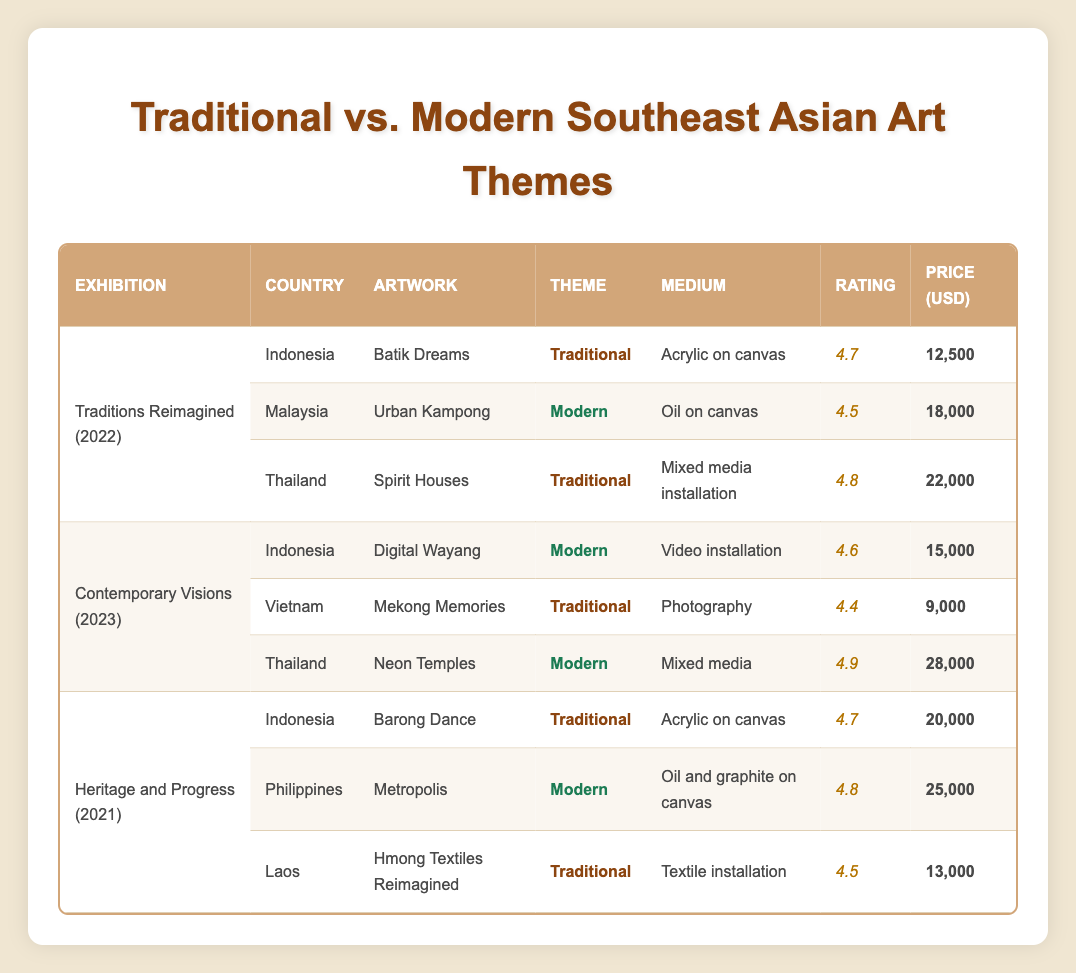What is the artwork with the highest sales price? By scanning through the sales prices in the table, the artwork "Neon Temples" by Korakrit Arunanondchai from Thailand has the highest sales price of 28,000 USD.
Answer: 28,000 USD Which country has the most traditional artworks in the exhibitions? Looking at the number of traditional artworks listed in the exhibitions, Indonesia has two traditional artworks, namely "Batik Dreams" and "Barong Dance." Other countries have either one or none.
Answer: Indonesia What is the average visitor rating for modern artworks across all exhibitions? The modern artworks and their ratings are: 4.5 (Urban Kampong), 4.6 (Digital Wayang), 4.9 (Neon Temples), and 4.8 (Metropolis). Adding these gives a total of 18.8. There are 4 modern artworks, so the average rating is 18.8/4 = 4.7.
Answer: 4.7 Is there an artwork with a visitor rating of 4.9? Yes, there is an artwork titled "Neon Temples" by Korakrit Arunanondchai that has a visitor rating of 4.9 listed in the table.
Answer: Yes Which exhibition featured the highest number of traditional artworks? The exhibitions "Traditions Reimagined," "Contemporary Visions," and "Heritage and Progress" each include three artworks, with "Traditions Reimagined" and "Heritage and Progress" each containing two traditional artworks each, while "Contemporary Visions" has one traditional artwork. Hence, both "Traditions Reimagined" and "Heritage and Progress" tie for the highest number of traditional artworks.
Answer: Traditions Reimagined, Heritage and Progress What is the difference in sales price between the most expensive modern artwork and the least expensive traditional artwork? The most expensive modern artwork is "Neon Temples" at 28,000 USD, and the least expensive traditional artwork is "Mekong Memories" at 9,000 USD. The difference is 28,000 - 9,000 = 19,000 USD.
Answer: 19,000 USD 